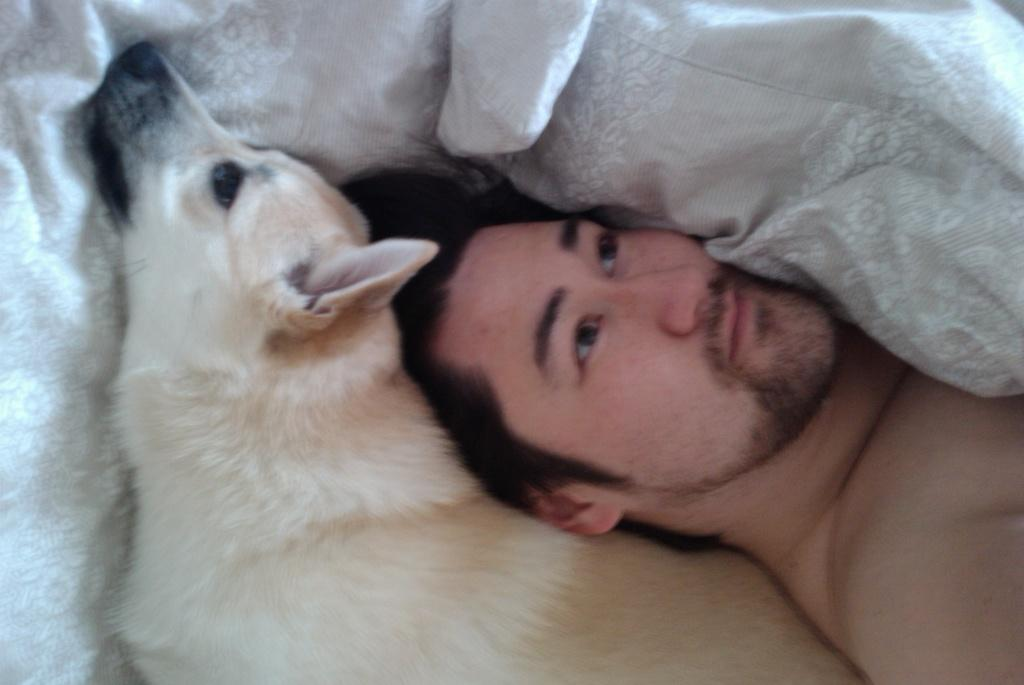What is present in the image along with the person? There is a white-colored dog in the image. What is the dog doing in the image? The dog is sleeping on the bed. What color is the blanket in the image? The blanket in the image is white-colored. Can you describe the context of the image? The person and the dog are likely sleeping, based on the context. What type of finger can be seen pointing at the moon in the image? There is no finger or moon present in the image. 